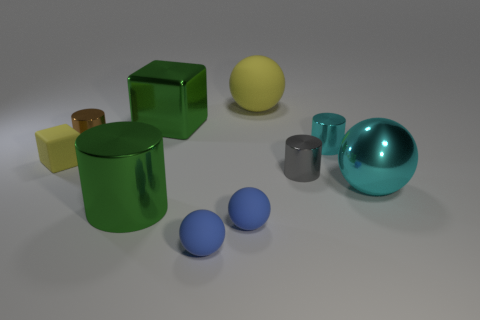Subtract all cyan cylinders. How many cylinders are left? 3 Subtract all cyan cylinders. How many blue balls are left? 2 Subtract all yellow spheres. How many spheres are left? 3 Subtract 1 balls. How many balls are left? 3 Subtract all brown balls. Subtract all blue blocks. How many balls are left? 4 Subtract 0 brown spheres. How many objects are left? 10 Subtract all balls. How many objects are left? 6 Subtract all large cylinders. Subtract all cyan cylinders. How many objects are left? 8 Add 6 yellow matte balls. How many yellow matte balls are left? 7 Add 5 brown metallic things. How many brown metallic things exist? 6 